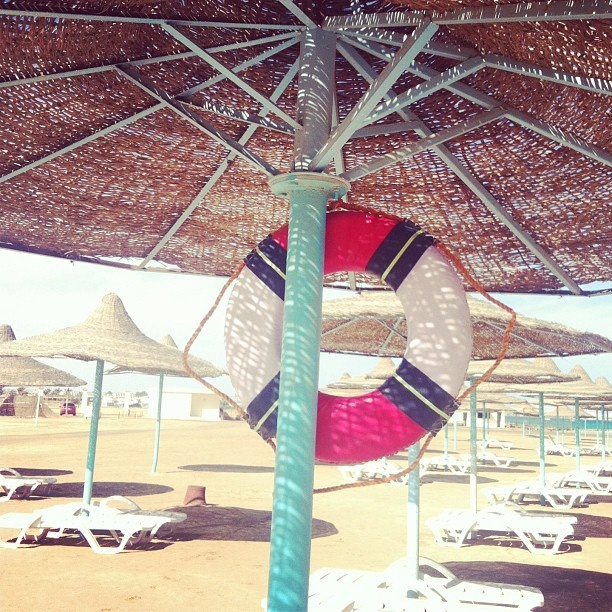Describe the objects in this image and their specific colors. I can see umbrella in black, gray, maroon, brown, and darkgray tones, umbrella in black, beige, darkgray, and tan tones, bench in black, ivory, beige, darkgray, and brown tones, chair in black, ivory, darkgray, lightgray, and gray tones, and umbrella in black, darkgray, gray, and beige tones in this image. 